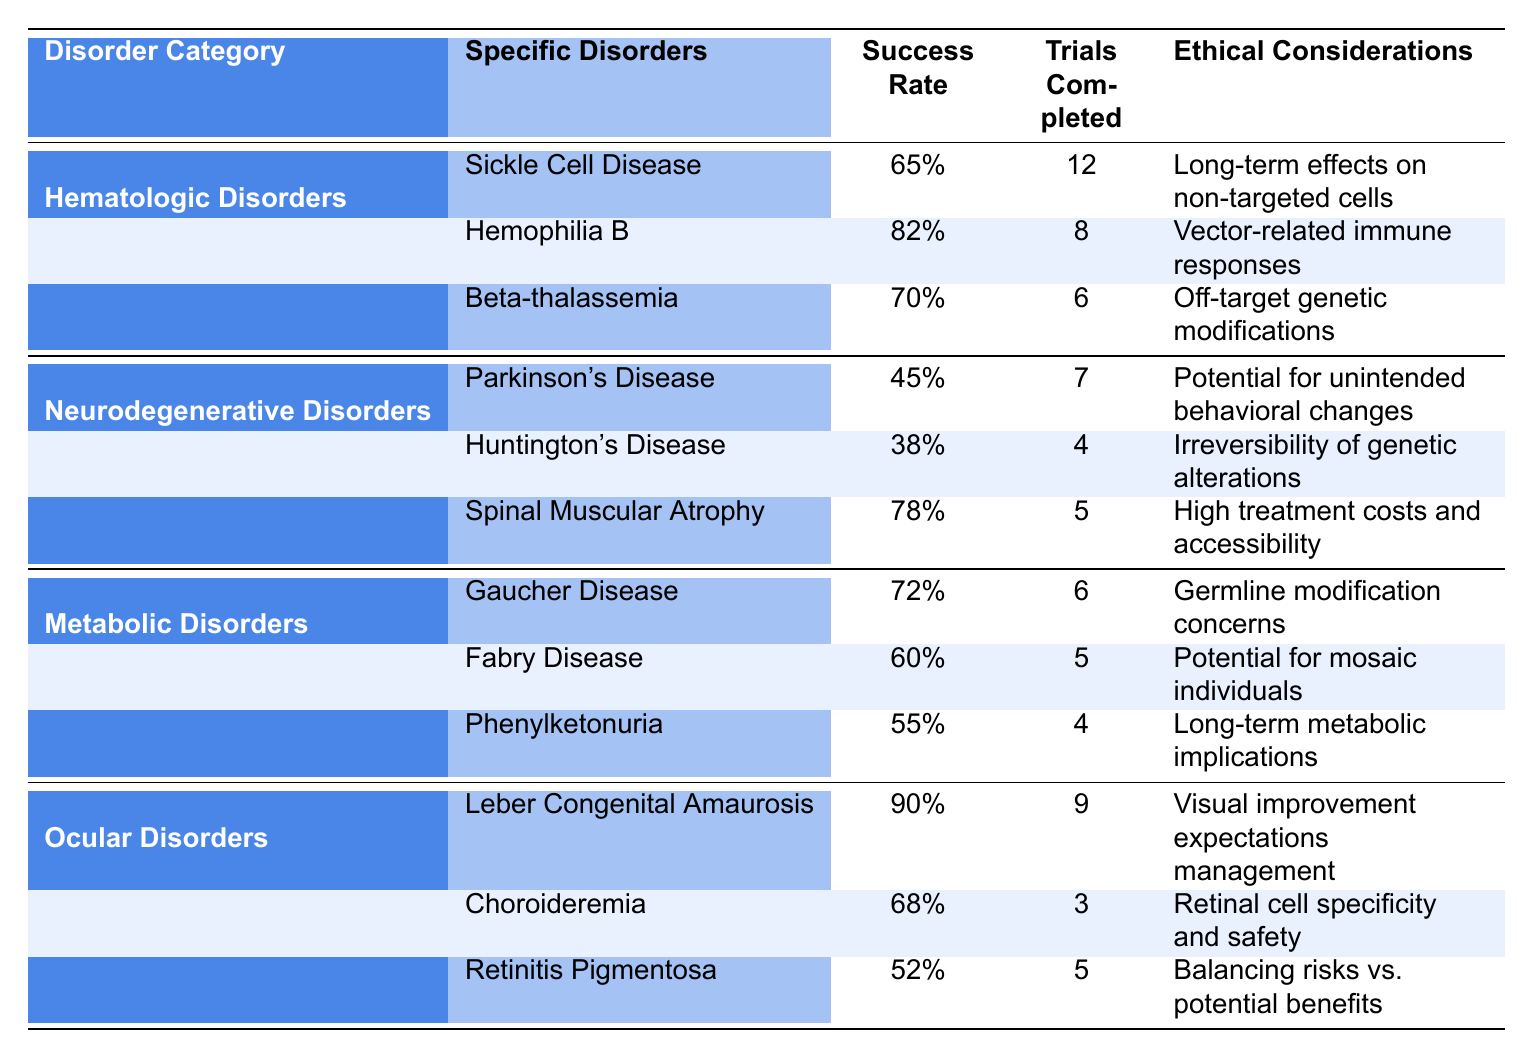What is the success rate for Sickle Cell Disease? The table shows a specific disorder under Hematologic Disorders with a success rate of 65% for Sickle Cell Disease.
Answer: 65% Which disorder has the highest success rate? Comparing the success rates across all categories, Leber Congenital Amaurosis is highlighted as having the highest success rate of 90%.
Answer: 90% What is the average success rate of the Neurodegenerative Disorders listed? The success rates for Neurodegenerative Disorders are 45%, 38%, and 78%. Summing them gives 45 + 38 + 78 = 161. To find the average, divide by the number of disorders, which is 3: 161 / 3 ≈ 53.67%.
Answer: 53.67% How many trials were completed for Hemophilia B? The table directly indicates that there were 8 trials completed for Hemophilia B.
Answer: 8 What is the difference in success rates between Gaucher Disease and Fabry Disease? Gaucher Disease has a success rate of 72%, while Fabry Disease has a success rate of 60%. The difference is calculated as 72 - 60 = 12%.
Answer: 12% Is the success rate for Huntington's Disease greater than 50%? The table indicates that the success rate for Huntington's Disease is 38%, which is less than 50%.
Answer: No Which disorder's ethical considerations mention high treatment costs? The ethical considerations for Spinal Muscular Atrophy mention "high treatment costs and accessibility."
Answer: Spinal Muscular Atrophy What percentage of success is noted for disorders in the Metabolic category? The success rates for the Metabolic Disorders are 72%, 60%, and 55%. The average is: (72 + 60 + 55) / 3 = 62.33%.
Answer: 62.33% How many specific disorders in the Ocular Disorders category have a success rate less than 60%? In the Ocular Disorders category, Retinitis Pigmentosa has a success rate of 52%, which is the only one less than 60%.
Answer: 1 What is the overall success rate for the Hematologic Disorders? The success rates for Hematologic Disorders are 65%, 82%, and 70%. The average is (65 + 82 + 70) / 3 = 72.33%.
Answer: 72.33% 